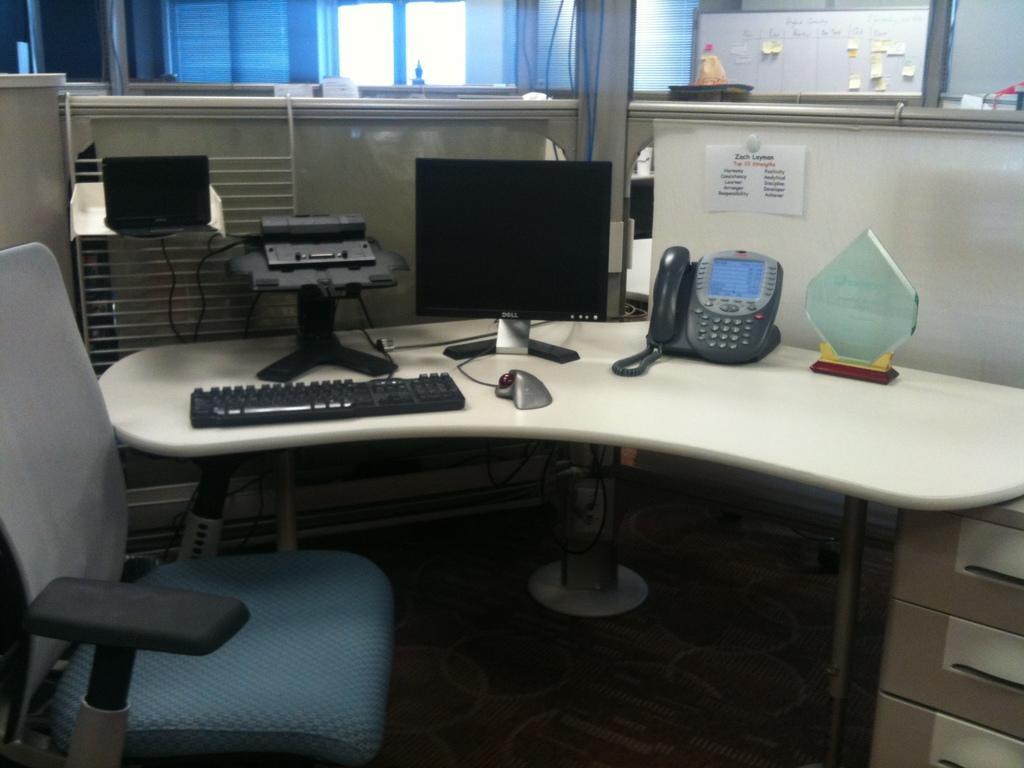Describe this image in one or two sentences. there is a chair and desk. on the desk there is a monitor, keyboard , mouse and a telephone. a paper note is attached to the desk. behind the desk there is a board on which paper slips are sticked. 